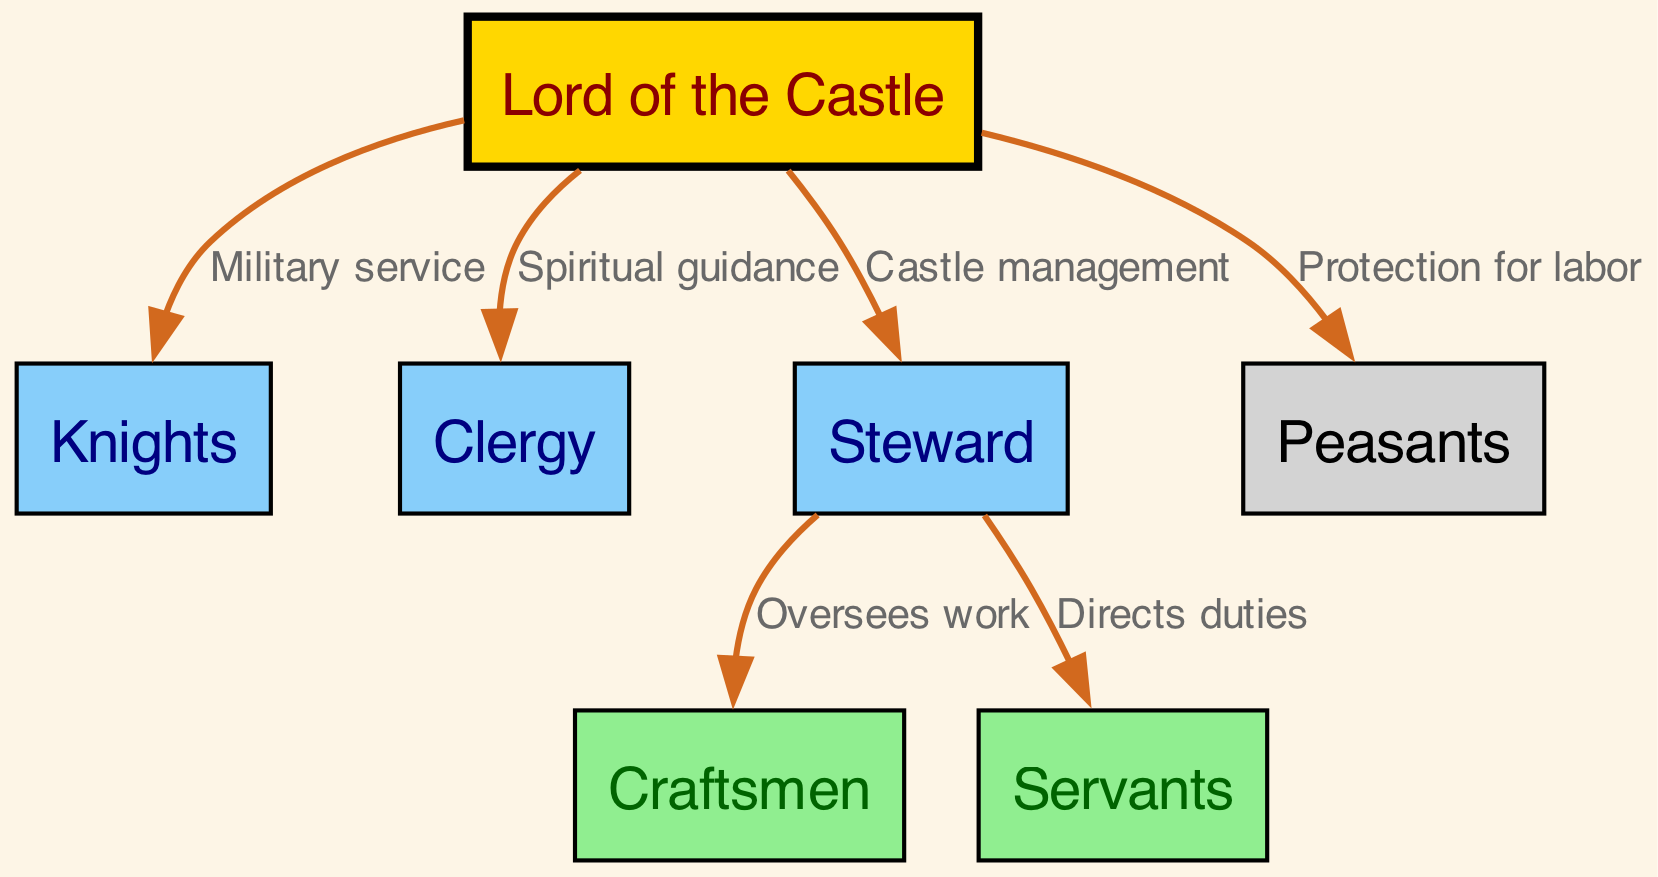What is the highest status in the castle hierarchy? The diagram shows "Lord of the Castle" at the top, indicating that this is the highest status in the hierarchy.
Answer: Lord of the Castle How many nodes are present in the diagram? The diagram includes 7 nodes representing different roles within the castle, which can be counted directly from the node section of the data.
Answer: 7 What is the relationship between the Lord and the Knights? The diagram indicates that the Lord has a "Military service" relationship with the Knights, connecting these two nodes directly with that label.
Answer: Military service Which group receives "Spiritual guidance" from the Lord? The edge labeled "Spiritual guidance" connects the Lord to the Clergy, indicating this relationship as shown in the diagram.
Answer: Clergy What role oversees the work of the Craftsmen? The diagram states that the Steward "Oversees work" of the Craftsmen, indicating a direct supervisory relationship between these two.
Answer: Steward Which group is directly instructed by the Steward? The diagram shows that the Steward "Directs duties" of the Servants, indicating this direct instruction from the Steward to Servants.
Answer: Servants What do the Peasants receive from the Lord? The diagram indicates that the Lord provides "Protection for labor" to the Peasants, establishing this as a key aspect of their relationship.
Answer: Protection for labor What color represents the Lord of the Castle node? The diagram specifies that the Lord node is filled with the color "gold," distinguishing it visually from other nodes.
Answer: Gold What is the overall role of the Steward within the castle? Analyzing the connections, the Steward is responsible for "Castle management" as directed by the Lord, overseeing both craftsmen and servants.
Answer: Castle management 